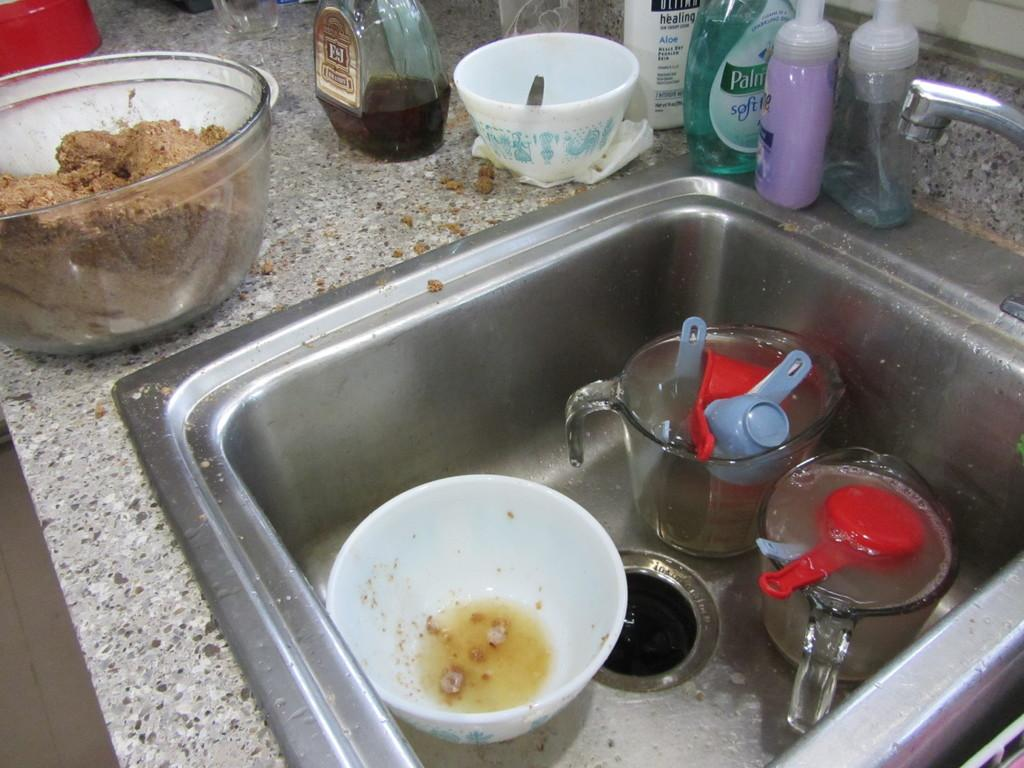What type of dishes can be seen in the kitchen sink? There are bowls and mugs in the kitchen sink. What utensils are present in the kitchen sink? Spoons are present in the kitchen sink. What items are located beside the kitchen sink? There is a bottle, sanitizers, and tissues beside the kitchen sink. Are there any additional bowls near the kitchen sink? Yes, there are additional bowls beside the kitchen sink. Can you see any lifts in the image? There are no lifts present in the image; it features a kitchen sink with dishes, utensils, and items beside it. What type of skin is visible in the image? There is no skin visible in the image; it features a kitchen sink with dishes, utensils, and items beside it. 